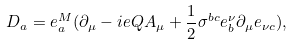Convert formula to latex. <formula><loc_0><loc_0><loc_500><loc_500>D _ { a } = e ^ { M } _ { a } ( \partial _ { \mu } - i e Q A _ { \mu } + \frac { 1 } { 2 } \sigma ^ { b c } e _ { b } ^ { \nu } \partial _ { \mu } e _ { \nu c } ) ,</formula> 